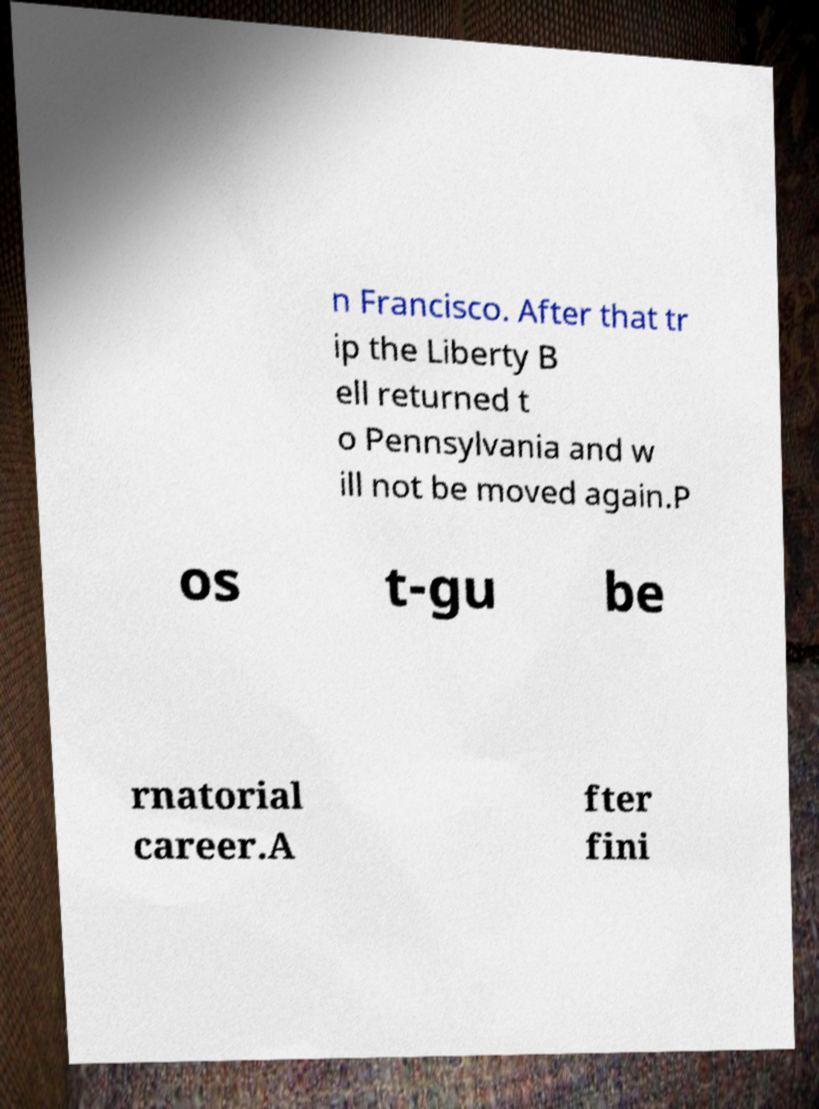I need the written content from this picture converted into text. Can you do that? n Francisco. After that tr ip the Liberty B ell returned t o Pennsylvania and w ill not be moved again.P os t-gu be rnatorial career.A fter fini 